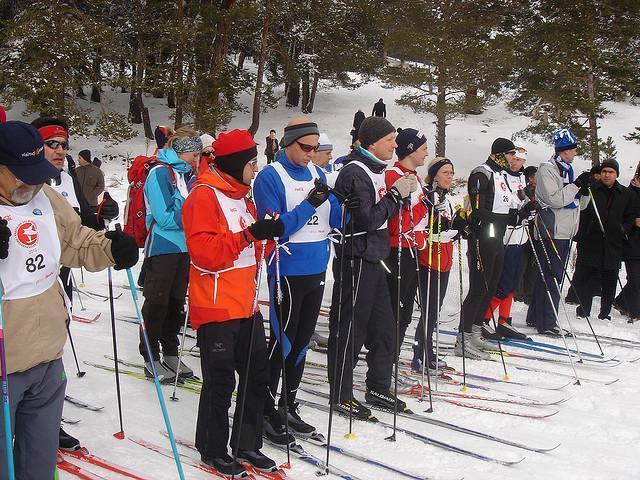How many ski are there?
Give a very brief answer. 2. How many people are in the picture?
Give a very brief answer. 10. 